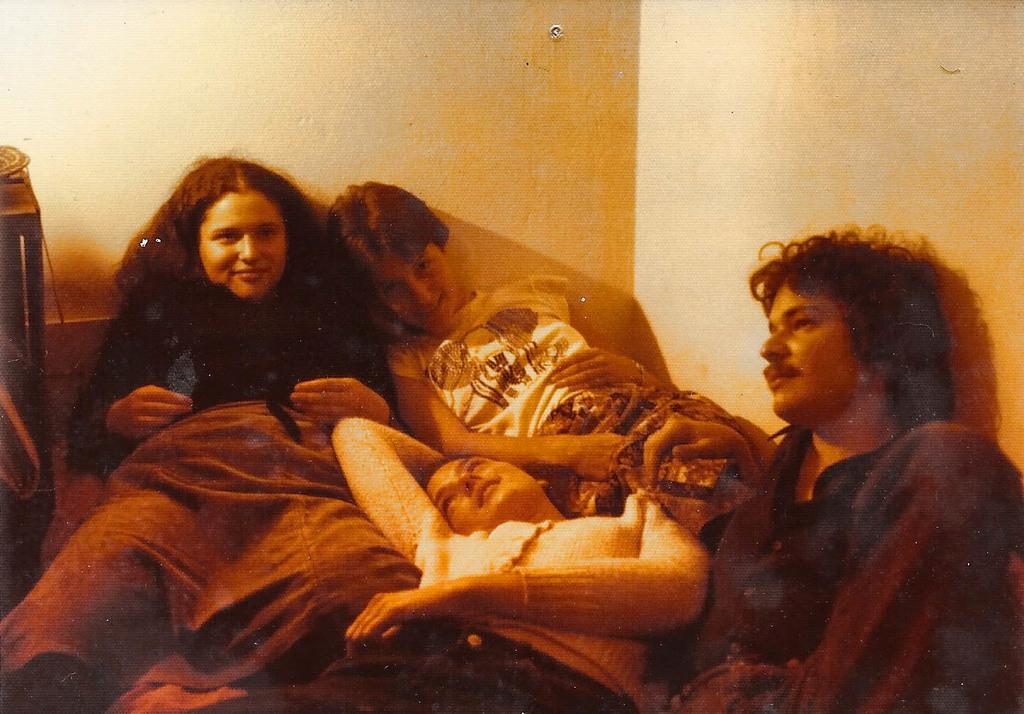How many people are in the image? There are four persons in the image. What is the facial expression of most of the people in the image? Three of the persons are smiling. What can be seen in the background of the image? There is a wall in the image, and shadows are visible on the wall. Can you describe the unspecified "thing" in the image? Unfortunately, the provided facts do not give any details about the "thing" in the image. What type of birthday celebration is happening in the image? There is no indication of a birthday celebration in the image. How many grandmothers are present in the image? There is no mention of a grandmother or any family members in the image. 